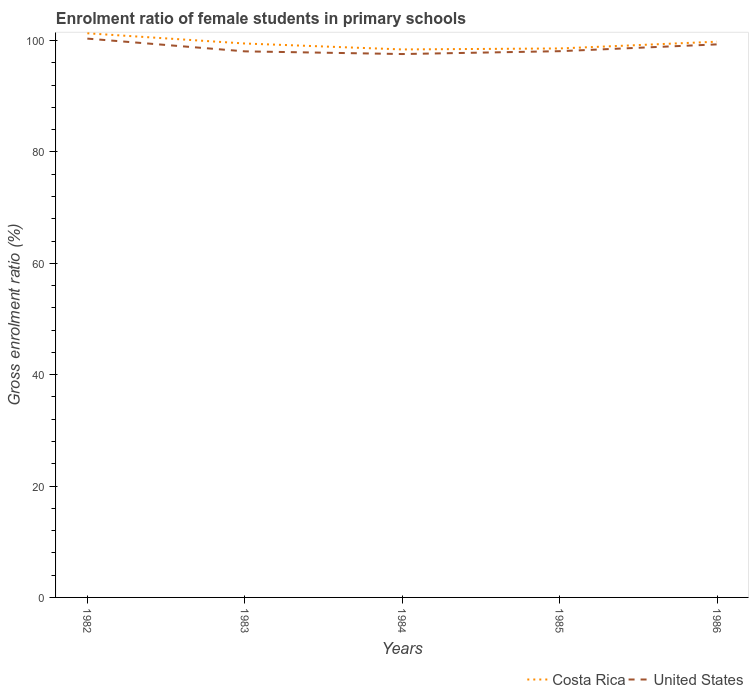Is the number of lines equal to the number of legend labels?
Provide a short and direct response. Yes. Across all years, what is the maximum enrolment ratio of female students in primary schools in Costa Rica?
Provide a short and direct response. 98.42. In which year was the enrolment ratio of female students in primary schools in United States maximum?
Your answer should be very brief. 1984. What is the total enrolment ratio of female students in primary schools in Costa Rica in the graph?
Ensure brevity in your answer.  1.51. What is the difference between the highest and the second highest enrolment ratio of female students in primary schools in Costa Rica?
Your answer should be compact. 2.9. How many lines are there?
Make the answer very short. 2. How many years are there in the graph?
Give a very brief answer. 5. What is the difference between two consecutive major ticks on the Y-axis?
Give a very brief answer. 20. Does the graph contain grids?
Your answer should be compact. No. Where does the legend appear in the graph?
Ensure brevity in your answer.  Bottom right. What is the title of the graph?
Offer a very short reply. Enrolment ratio of female students in primary schools. What is the Gross enrolment ratio (%) in Costa Rica in 1982?
Offer a very short reply. 101.32. What is the Gross enrolment ratio (%) in United States in 1982?
Keep it short and to the point. 100.36. What is the Gross enrolment ratio (%) of Costa Rica in 1983?
Provide a succinct answer. 99.48. What is the Gross enrolment ratio (%) in United States in 1983?
Offer a very short reply. 98.07. What is the Gross enrolment ratio (%) in Costa Rica in 1984?
Your answer should be compact. 98.42. What is the Gross enrolment ratio (%) of United States in 1984?
Provide a succinct answer. 97.59. What is the Gross enrolment ratio (%) of Costa Rica in 1985?
Your response must be concise. 98.59. What is the Gross enrolment ratio (%) in United States in 1985?
Provide a short and direct response. 98.11. What is the Gross enrolment ratio (%) of Costa Rica in 1986?
Offer a very short reply. 99.81. What is the Gross enrolment ratio (%) in United States in 1986?
Give a very brief answer. 99.33. Across all years, what is the maximum Gross enrolment ratio (%) of Costa Rica?
Your answer should be very brief. 101.32. Across all years, what is the maximum Gross enrolment ratio (%) of United States?
Keep it short and to the point. 100.36. Across all years, what is the minimum Gross enrolment ratio (%) in Costa Rica?
Provide a short and direct response. 98.42. Across all years, what is the minimum Gross enrolment ratio (%) of United States?
Keep it short and to the point. 97.59. What is the total Gross enrolment ratio (%) in Costa Rica in the graph?
Your response must be concise. 497.63. What is the total Gross enrolment ratio (%) in United States in the graph?
Your answer should be compact. 493.46. What is the difference between the Gross enrolment ratio (%) of Costa Rica in 1982 and that in 1983?
Your answer should be compact. 1.83. What is the difference between the Gross enrolment ratio (%) of United States in 1982 and that in 1983?
Your answer should be compact. 2.29. What is the difference between the Gross enrolment ratio (%) in Costa Rica in 1982 and that in 1984?
Provide a succinct answer. 2.9. What is the difference between the Gross enrolment ratio (%) in United States in 1982 and that in 1984?
Keep it short and to the point. 2.77. What is the difference between the Gross enrolment ratio (%) in Costa Rica in 1982 and that in 1985?
Your answer should be very brief. 2.73. What is the difference between the Gross enrolment ratio (%) of United States in 1982 and that in 1985?
Your answer should be compact. 2.26. What is the difference between the Gross enrolment ratio (%) in Costa Rica in 1982 and that in 1986?
Ensure brevity in your answer.  1.51. What is the difference between the Gross enrolment ratio (%) in United States in 1982 and that in 1986?
Your answer should be compact. 1.04. What is the difference between the Gross enrolment ratio (%) of Costa Rica in 1983 and that in 1984?
Provide a short and direct response. 1.07. What is the difference between the Gross enrolment ratio (%) of United States in 1983 and that in 1984?
Your answer should be compact. 0.48. What is the difference between the Gross enrolment ratio (%) of Costa Rica in 1983 and that in 1985?
Your answer should be very brief. 0.89. What is the difference between the Gross enrolment ratio (%) in United States in 1983 and that in 1985?
Your response must be concise. -0.03. What is the difference between the Gross enrolment ratio (%) in Costa Rica in 1983 and that in 1986?
Provide a succinct answer. -0.33. What is the difference between the Gross enrolment ratio (%) of United States in 1983 and that in 1986?
Your response must be concise. -1.25. What is the difference between the Gross enrolment ratio (%) of Costa Rica in 1984 and that in 1985?
Keep it short and to the point. -0.17. What is the difference between the Gross enrolment ratio (%) in United States in 1984 and that in 1985?
Give a very brief answer. -0.51. What is the difference between the Gross enrolment ratio (%) in Costa Rica in 1984 and that in 1986?
Your answer should be compact. -1.39. What is the difference between the Gross enrolment ratio (%) of United States in 1984 and that in 1986?
Make the answer very short. -1.74. What is the difference between the Gross enrolment ratio (%) of Costa Rica in 1985 and that in 1986?
Your response must be concise. -1.22. What is the difference between the Gross enrolment ratio (%) in United States in 1985 and that in 1986?
Your answer should be compact. -1.22. What is the difference between the Gross enrolment ratio (%) of Costa Rica in 1982 and the Gross enrolment ratio (%) of United States in 1983?
Your answer should be very brief. 3.24. What is the difference between the Gross enrolment ratio (%) in Costa Rica in 1982 and the Gross enrolment ratio (%) in United States in 1984?
Your answer should be compact. 3.73. What is the difference between the Gross enrolment ratio (%) of Costa Rica in 1982 and the Gross enrolment ratio (%) of United States in 1985?
Give a very brief answer. 3.21. What is the difference between the Gross enrolment ratio (%) of Costa Rica in 1982 and the Gross enrolment ratio (%) of United States in 1986?
Make the answer very short. 1.99. What is the difference between the Gross enrolment ratio (%) of Costa Rica in 1983 and the Gross enrolment ratio (%) of United States in 1984?
Your answer should be compact. 1.89. What is the difference between the Gross enrolment ratio (%) of Costa Rica in 1983 and the Gross enrolment ratio (%) of United States in 1985?
Give a very brief answer. 1.38. What is the difference between the Gross enrolment ratio (%) in Costa Rica in 1983 and the Gross enrolment ratio (%) in United States in 1986?
Provide a succinct answer. 0.16. What is the difference between the Gross enrolment ratio (%) in Costa Rica in 1984 and the Gross enrolment ratio (%) in United States in 1985?
Provide a succinct answer. 0.31. What is the difference between the Gross enrolment ratio (%) in Costa Rica in 1984 and the Gross enrolment ratio (%) in United States in 1986?
Make the answer very short. -0.91. What is the difference between the Gross enrolment ratio (%) in Costa Rica in 1985 and the Gross enrolment ratio (%) in United States in 1986?
Offer a terse response. -0.73. What is the average Gross enrolment ratio (%) of Costa Rica per year?
Your answer should be very brief. 99.53. What is the average Gross enrolment ratio (%) of United States per year?
Provide a short and direct response. 98.69. In the year 1982, what is the difference between the Gross enrolment ratio (%) in Costa Rica and Gross enrolment ratio (%) in United States?
Provide a short and direct response. 0.96. In the year 1983, what is the difference between the Gross enrolment ratio (%) in Costa Rica and Gross enrolment ratio (%) in United States?
Give a very brief answer. 1.41. In the year 1984, what is the difference between the Gross enrolment ratio (%) of Costa Rica and Gross enrolment ratio (%) of United States?
Offer a very short reply. 0.83. In the year 1985, what is the difference between the Gross enrolment ratio (%) of Costa Rica and Gross enrolment ratio (%) of United States?
Offer a terse response. 0.49. In the year 1986, what is the difference between the Gross enrolment ratio (%) in Costa Rica and Gross enrolment ratio (%) in United States?
Give a very brief answer. 0.49. What is the ratio of the Gross enrolment ratio (%) in Costa Rica in 1982 to that in 1983?
Your answer should be compact. 1.02. What is the ratio of the Gross enrolment ratio (%) in United States in 1982 to that in 1983?
Your response must be concise. 1.02. What is the ratio of the Gross enrolment ratio (%) in Costa Rica in 1982 to that in 1984?
Make the answer very short. 1.03. What is the ratio of the Gross enrolment ratio (%) in United States in 1982 to that in 1984?
Offer a very short reply. 1.03. What is the ratio of the Gross enrolment ratio (%) in Costa Rica in 1982 to that in 1985?
Provide a succinct answer. 1.03. What is the ratio of the Gross enrolment ratio (%) in Costa Rica in 1982 to that in 1986?
Make the answer very short. 1.02. What is the ratio of the Gross enrolment ratio (%) of United States in 1982 to that in 1986?
Keep it short and to the point. 1.01. What is the ratio of the Gross enrolment ratio (%) of Costa Rica in 1983 to that in 1984?
Offer a terse response. 1.01. What is the ratio of the Gross enrolment ratio (%) in United States in 1983 to that in 1984?
Your response must be concise. 1. What is the ratio of the Gross enrolment ratio (%) of United States in 1983 to that in 1985?
Offer a very short reply. 1. What is the ratio of the Gross enrolment ratio (%) of Costa Rica in 1983 to that in 1986?
Offer a terse response. 1. What is the ratio of the Gross enrolment ratio (%) of United States in 1983 to that in 1986?
Give a very brief answer. 0.99. What is the ratio of the Gross enrolment ratio (%) in United States in 1984 to that in 1985?
Ensure brevity in your answer.  0.99. What is the ratio of the Gross enrolment ratio (%) in United States in 1984 to that in 1986?
Offer a terse response. 0.98. What is the ratio of the Gross enrolment ratio (%) of Costa Rica in 1985 to that in 1986?
Ensure brevity in your answer.  0.99. What is the ratio of the Gross enrolment ratio (%) in United States in 1985 to that in 1986?
Keep it short and to the point. 0.99. What is the difference between the highest and the second highest Gross enrolment ratio (%) in Costa Rica?
Give a very brief answer. 1.51. What is the difference between the highest and the second highest Gross enrolment ratio (%) of United States?
Provide a short and direct response. 1.04. What is the difference between the highest and the lowest Gross enrolment ratio (%) in Costa Rica?
Make the answer very short. 2.9. What is the difference between the highest and the lowest Gross enrolment ratio (%) of United States?
Keep it short and to the point. 2.77. 